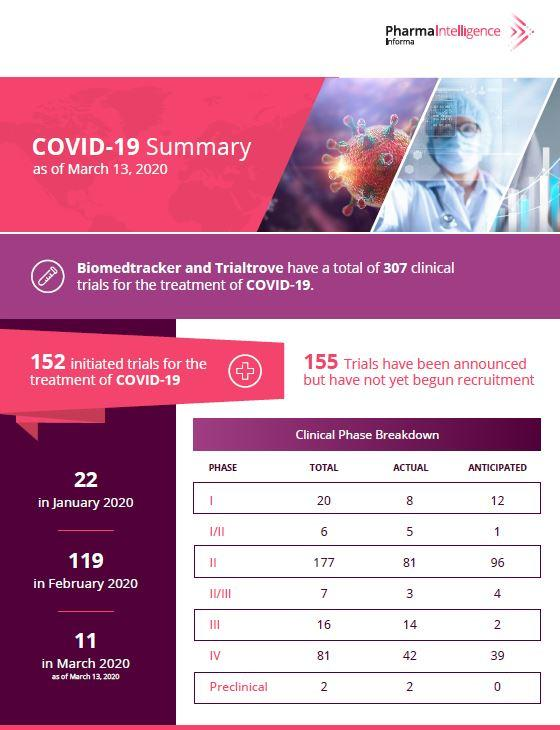Give some essential details in this illustration. There were a total of 130 clinical trials initiated in the months of March and February combined. Based on the table, the total number of anticipated clinical trials is 309. The total number of anticipated clinical trials is 154. The most number of actual clinical trials are currently taking place in phase II. There are currently 155 actual clinical trials taking place in various phases. 